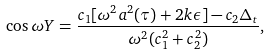Convert formula to latex. <formula><loc_0><loc_0><loc_500><loc_500>\cos { \omega Y } = \frac { c _ { 1 } [ \omega ^ { 2 } a ^ { 2 } ( \tau ) + 2 k \epsilon ] - c _ { 2 } \Delta _ { t } } { \omega ^ { 2 } ( c _ { 1 } ^ { 2 } + c _ { 2 } ^ { 2 } ) } ,</formula> 